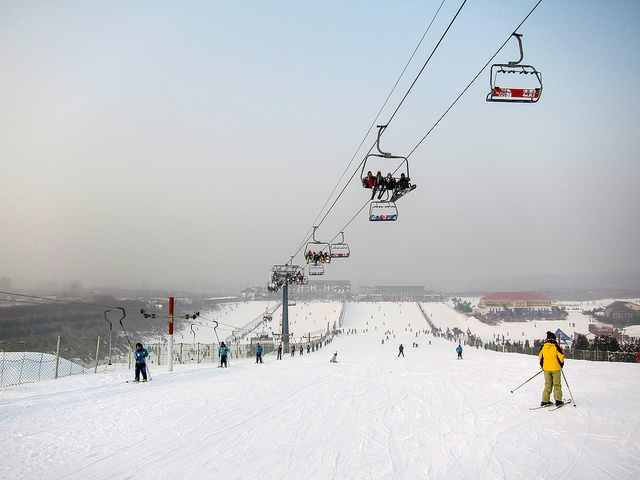Describe the objects in this image and their specific colors. I can see people in lightgray, darkgray, gray, and black tones, people in lightgray, orange, black, and olive tones, people in lightgray, black, navy, gray, and blue tones, people in lightgray, black, gray, and darkgray tones, and people in lightgray, black, gray, teal, and darkgray tones in this image. 